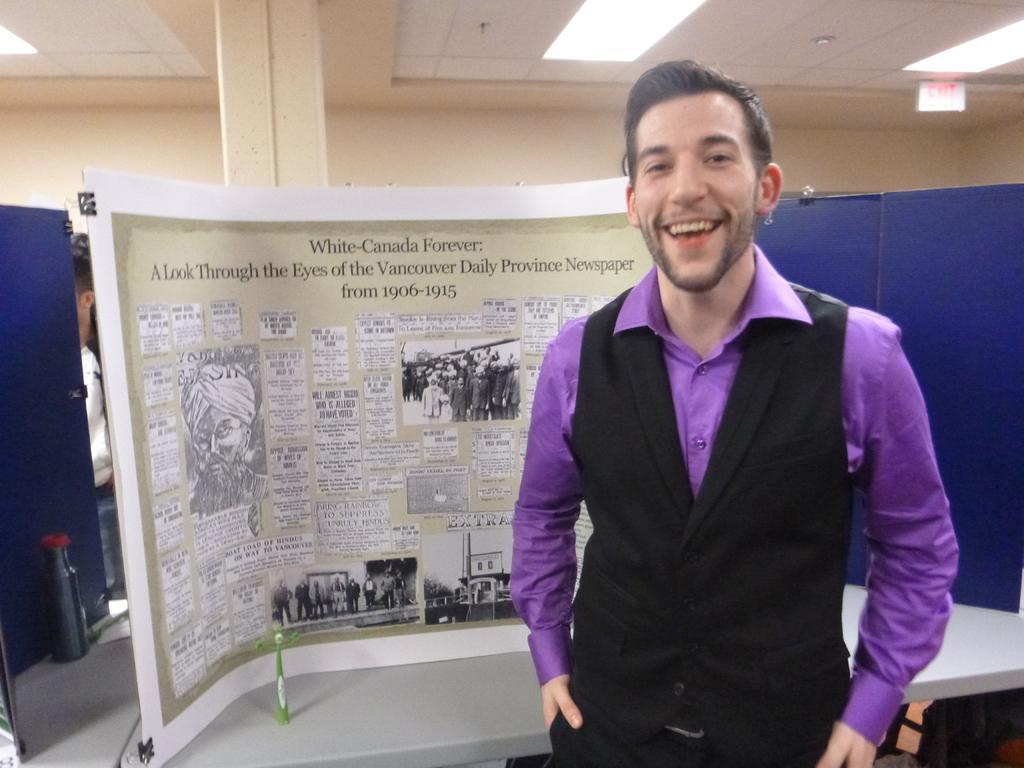Can you describe this image briefly? In this image I can see a man standing behind him there are some notice boards, also there is a pillar and lights on the ceiling. 